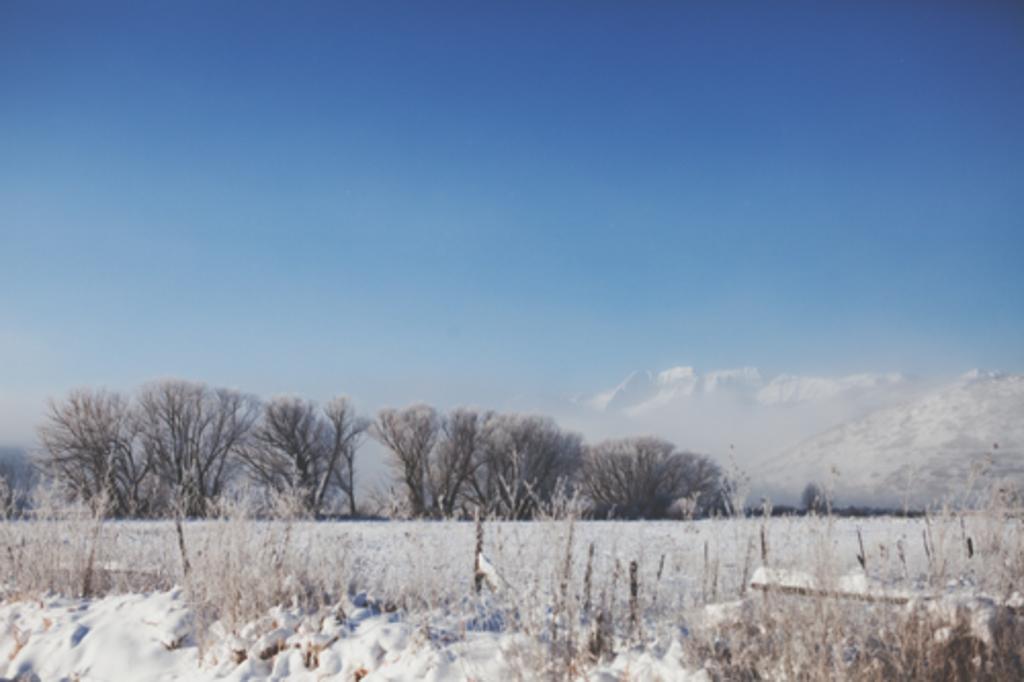Could you give a brief overview of what you see in this image? In this image, I can see the trees and plants. At the bottom of the image, that looks like the snow. In the background, I think these are the snowy mountains. At the top of the image, I can see the sky. 